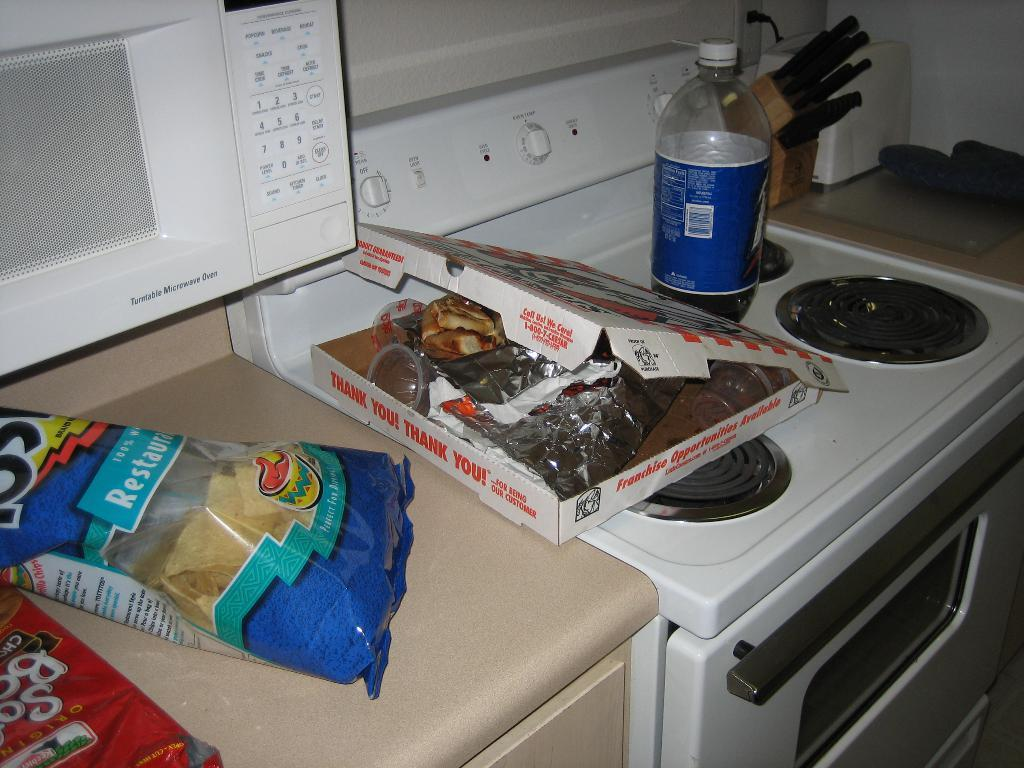<image>
Render a clear and concise summary of the photo. A pizza box sits next to a bag of Tostitos chips. 